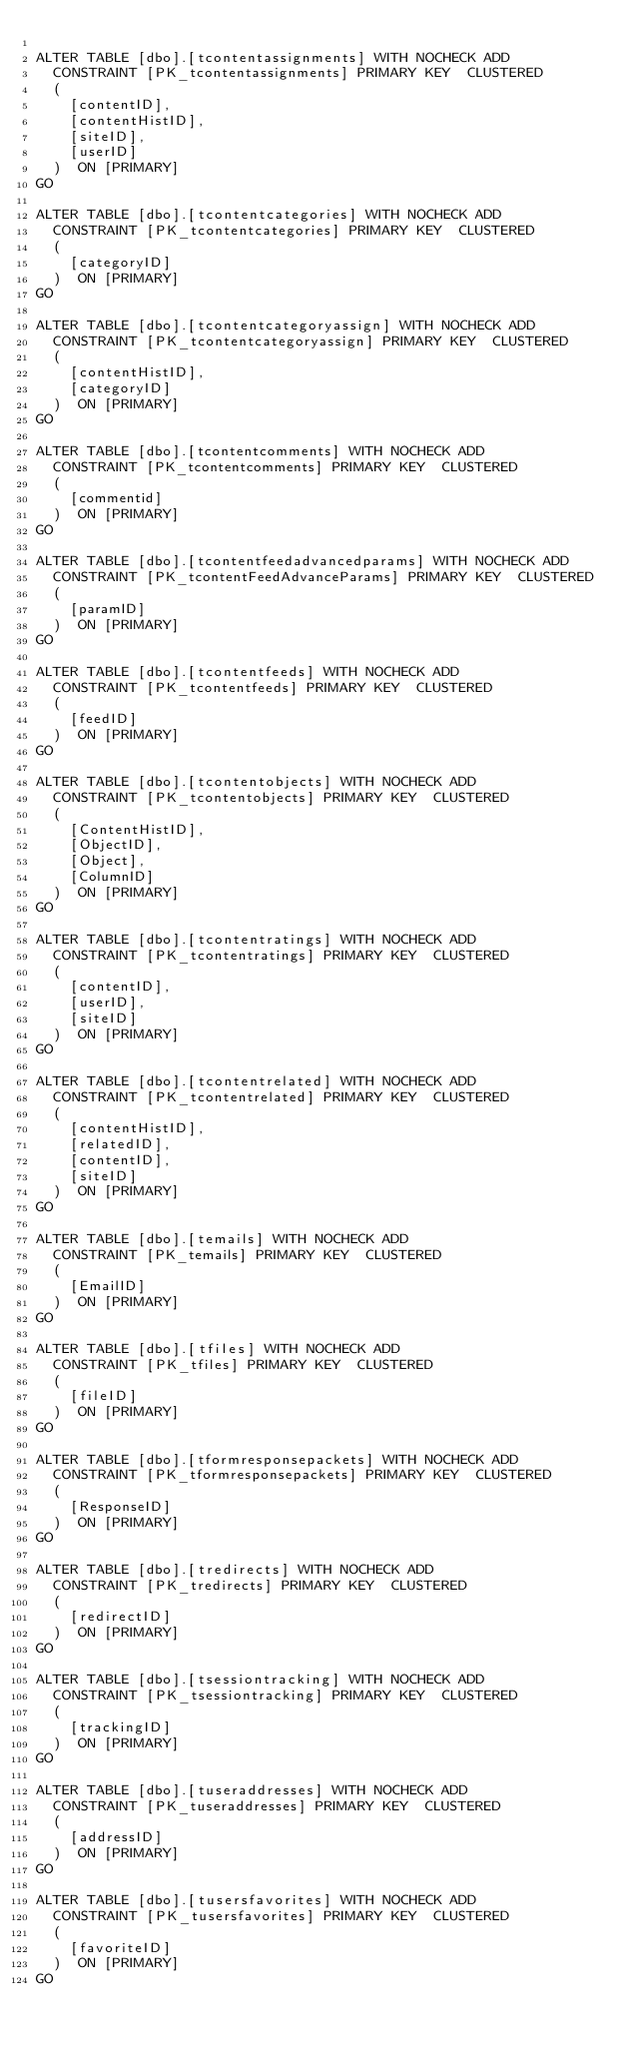Convert code to text. <code><loc_0><loc_0><loc_500><loc_500><_SQL_>
ALTER TABLE [dbo].[tcontentassignments] WITH NOCHECK ADD
	CONSTRAINT [PK_tcontentassignments] PRIMARY KEY  CLUSTERED
	(
		[contentID],
		[contentHistID],
		[siteID],
		[userID]
	)  ON [PRIMARY]
GO

ALTER TABLE [dbo].[tcontentcategories] WITH NOCHECK ADD
	CONSTRAINT [PK_tcontentcategories] PRIMARY KEY  CLUSTERED
	(
		[categoryID]
	)  ON [PRIMARY]
GO

ALTER TABLE [dbo].[tcontentcategoryassign] WITH NOCHECK ADD
	CONSTRAINT [PK_tcontentcategoryassign] PRIMARY KEY  CLUSTERED
	(
		[contentHistID],
		[categoryID]
	)  ON [PRIMARY]
GO

ALTER TABLE [dbo].[tcontentcomments] WITH NOCHECK ADD
	CONSTRAINT [PK_tcontentcomments] PRIMARY KEY  CLUSTERED
	(
		[commentid]
	)  ON [PRIMARY]
GO

ALTER TABLE [dbo].[tcontentfeedadvancedparams] WITH NOCHECK ADD
	CONSTRAINT [PK_tcontentFeedAdvanceParams] PRIMARY KEY  CLUSTERED
	(
		[paramID]
	)  ON [PRIMARY]
GO

ALTER TABLE [dbo].[tcontentfeeds] WITH NOCHECK ADD
	CONSTRAINT [PK_tcontentfeeds] PRIMARY KEY  CLUSTERED
	(
		[feedID]
	)  ON [PRIMARY]
GO

ALTER TABLE [dbo].[tcontentobjects] WITH NOCHECK ADD
	CONSTRAINT [PK_tcontentobjects] PRIMARY KEY  CLUSTERED
	(
		[ContentHistID],
		[ObjectID],
		[Object],
		[ColumnID]
	)  ON [PRIMARY]
GO

ALTER TABLE [dbo].[tcontentratings] WITH NOCHECK ADD
	CONSTRAINT [PK_tcontentratings] PRIMARY KEY  CLUSTERED
	(
		[contentID],
		[userID],
		[siteID]
	)  ON [PRIMARY]
GO

ALTER TABLE [dbo].[tcontentrelated] WITH NOCHECK ADD
	CONSTRAINT [PK_tcontentrelated] PRIMARY KEY  CLUSTERED
	(
		[contentHistID],
		[relatedID],
		[contentID],
		[siteID]
	)  ON [PRIMARY]
GO

ALTER TABLE [dbo].[temails] WITH NOCHECK ADD
	CONSTRAINT [PK_temails] PRIMARY KEY  CLUSTERED
	(
		[EmailID]
	)  ON [PRIMARY]
GO

ALTER TABLE [dbo].[tfiles] WITH NOCHECK ADD
	CONSTRAINT [PK_tfiles] PRIMARY KEY  CLUSTERED
	(
		[fileID]
	)  ON [PRIMARY]
GO

ALTER TABLE [dbo].[tformresponsepackets] WITH NOCHECK ADD
	CONSTRAINT [PK_tformresponsepackets] PRIMARY KEY  CLUSTERED
	(
		[ResponseID]
	)  ON [PRIMARY]
GO

ALTER TABLE [dbo].[tredirects] WITH NOCHECK ADD
	CONSTRAINT [PK_tredirects] PRIMARY KEY  CLUSTERED
	(
		[redirectID]
	)  ON [PRIMARY]
GO

ALTER TABLE [dbo].[tsessiontracking] WITH NOCHECK ADD
	CONSTRAINT [PK_tsessiontracking] PRIMARY KEY  CLUSTERED
	(
		[trackingID]
	)  ON [PRIMARY]
GO

ALTER TABLE [dbo].[tuseraddresses] WITH NOCHECK ADD
	CONSTRAINT [PK_tuseraddresses] PRIMARY KEY  CLUSTERED
	(
		[addressID]
	)  ON [PRIMARY]
GO

ALTER TABLE [dbo].[tusersfavorites] WITH NOCHECK ADD
	CONSTRAINT [PK_tusersfavorites] PRIMARY KEY  CLUSTERED
	(
		[favoriteID]
	)  ON [PRIMARY]
GO
</code> 